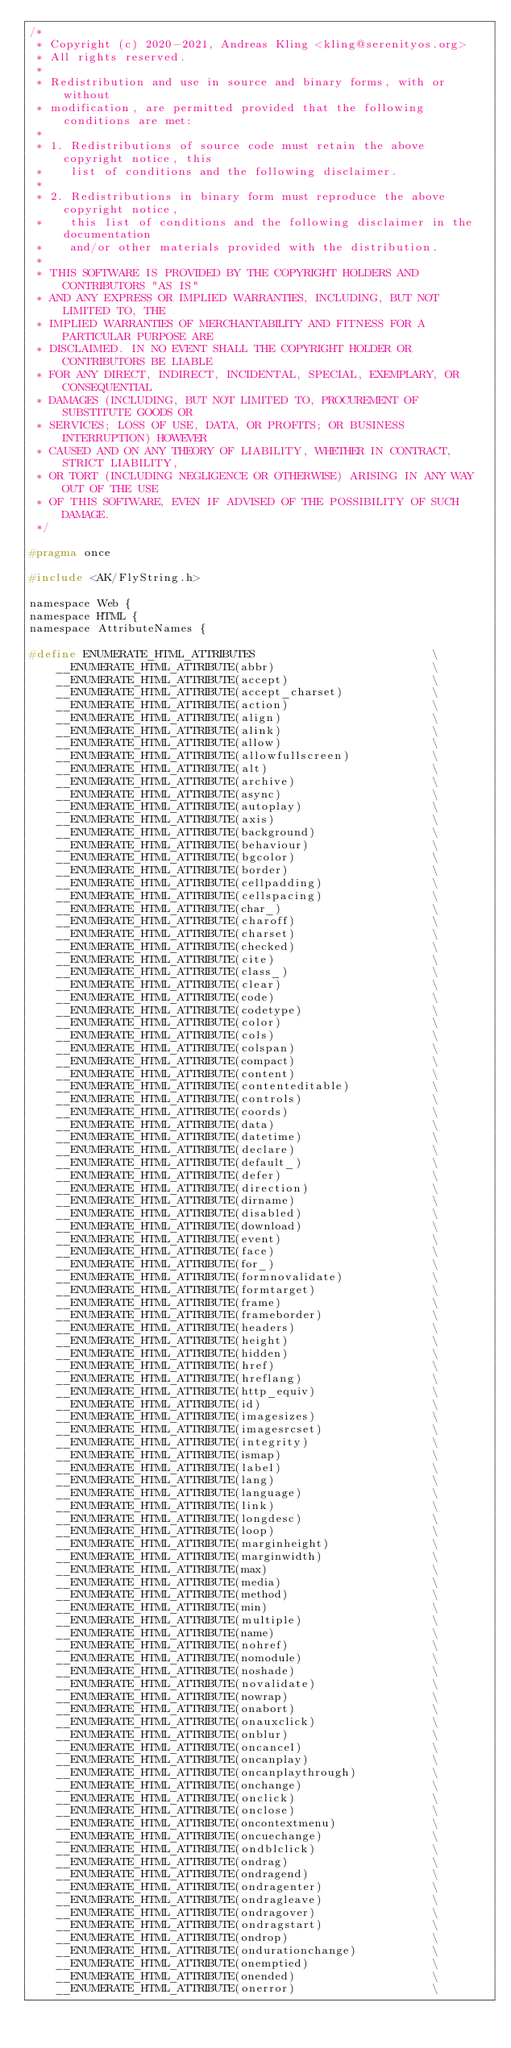Convert code to text. <code><loc_0><loc_0><loc_500><loc_500><_C_>/*
 * Copyright (c) 2020-2021, Andreas Kling <kling@serenityos.org>
 * All rights reserved.
 *
 * Redistribution and use in source and binary forms, with or without
 * modification, are permitted provided that the following conditions are met:
 *
 * 1. Redistributions of source code must retain the above copyright notice, this
 *    list of conditions and the following disclaimer.
 *
 * 2. Redistributions in binary form must reproduce the above copyright notice,
 *    this list of conditions and the following disclaimer in the documentation
 *    and/or other materials provided with the distribution.
 *
 * THIS SOFTWARE IS PROVIDED BY THE COPYRIGHT HOLDERS AND CONTRIBUTORS "AS IS"
 * AND ANY EXPRESS OR IMPLIED WARRANTIES, INCLUDING, BUT NOT LIMITED TO, THE
 * IMPLIED WARRANTIES OF MERCHANTABILITY AND FITNESS FOR A PARTICULAR PURPOSE ARE
 * DISCLAIMED. IN NO EVENT SHALL THE COPYRIGHT HOLDER OR CONTRIBUTORS BE LIABLE
 * FOR ANY DIRECT, INDIRECT, INCIDENTAL, SPECIAL, EXEMPLARY, OR CONSEQUENTIAL
 * DAMAGES (INCLUDING, BUT NOT LIMITED TO, PROCUREMENT OF SUBSTITUTE GOODS OR
 * SERVICES; LOSS OF USE, DATA, OR PROFITS; OR BUSINESS INTERRUPTION) HOWEVER
 * CAUSED AND ON ANY THEORY OF LIABILITY, WHETHER IN CONTRACT, STRICT LIABILITY,
 * OR TORT (INCLUDING NEGLIGENCE OR OTHERWISE) ARISING IN ANY WAY OUT OF THE USE
 * OF THIS SOFTWARE, EVEN IF ADVISED OF THE POSSIBILITY OF SUCH DAMAGE.
 */

#pragma once

#include <AK/FlyString.h>

namespace Web {
namespace HTML {
namespace AttributeNames {

#define ENUMERATE_HTML_ATTRIBUTES                          \
    __ENUMERATE_HTML_ATTRIBUTE(abbr)                       \
    __ENUMERATE_HTML_ATTRIBUTE(accept)                     \
    __ENUMERATE_HTML_ATTRIBUTE(accept_charset)             \
    __ENUMERATE_HTML_ATTRIBUTE(action)                     \
    __ENUMERATE_HTML_ATTRIBUTE(align)                      \
    __ENUMERATE_HTML_ATTRIBUTE(alink)                      \
    __ENUMERATE_HTML_ATTRIBUTE(allow)                      \
    __ENUMERATE_HTML_ATTRIBUTE(allowfullscreen)            \
    __ENUMERATE_HTML_ATTRIBUTE(alt)                        \
    __ENUMERATE_HTML_ATTRIBUTE(archive)                    \
    __ENUMERATE_HTML_ATTRIBUTE(async)                      \
    __ENUMERATE_HTML_ATTRIBUTE(autoplay)                   \
    __ENUMERATE_HTML_ATTRIBUTE(axis)                       \
    __ENUMERATE_HTML_ATTRIBUTE(background)                 \
    __ENUMERATE_HTML_ATTRIBUTE(behaviour)                  \
    __ENUMERATE_HTML_ATTRIBUTE(bgcolor)                    \
    __ENUMERATE_HTML_ATTRIBUTE(border)                     \
    __ENUMERATE_HTML_ATTRIBUTE(cellpadding)                \
    __ENUMERATE_HTML_ATTRIBUTE(cellspacing)                \
    __ENUMERATE_HTML_ATTRIBUTE(char_)                      \
    __ENUMERATE_HTML_ATTRIBUTE(charoff)                    \
    __ENUMERATE_HTML_ATTRIBUTE(charset)                    \
    __ENUMERATE_HTML_ATTRIBUTE(checked)                    \
    __ENUMERATE_HTML_ATTRIBUTE(cite)                       \
    __ENUMERATE_HTML_ATTRIBUTE(class_)                     \
    __ENUMERATE_HTML_ATTRIBUTE(clear)                      \
    __ENUMERATE_HTML_ATTRIBUTE(code)                       \
    __ENUMERATE_HTML_ATTRIBUTE(codetype)                   \
    __ENUMERATE_HTML_ATTRIBUTE(color)                      \
    __ENUMERATE_HTML_ATTRIBUTE(cols)                       \
    __ENUMERATE_HTML_ATTRIBUTE(colspan)                    \
    __ENUMERATE_HTML_ATTRIBUTE(compact)                    \
    __ENUMERATE_HTML_ATTRIBUTE(content)                    \
    __ENUMERATE_HTML_ATTRIBUTE(contenteditable)            \
    __ENUMERATE_HTML_ATTRIBUTE(controls)                   \
    __ENUMERATE_HTML_ATTRIBUTE(coords)                     \
    __ENUMERATE_HTML_ATTRIBUTE(data)                       \
    __ENUMERATE_HTML_ATTRIBUTE(datetime)                   \
    __ENUMERATE_HTML_ATTRIBUTE(declare)                    \
    __ENUMERATE_HTML_ATTRIBUTE(default_)                   \
    __ENUMERATE_HTML_ATTRIBUTE(defer)                      \
    __ENUMERATE_HTML_ATTRIBUTE(direction)                  \
    __ENUMERATE_HTML_ATTRIBUTE(dirname)                    \
    __ENUMERATE_HTML_ATTRIBUTE(disabled)                   \
    __ENUMERATE_HTML_ATTRIBUTE(download)                   \
    __ENUMERATE_HTML_ATTRIBUTE(event)                      \
    __ENUMERATE_HTML_ATTRIBUTE(face)                       \
    __ENUMERATE_HTML_ATTRIBUTE(for_)                       \
    __ENUMERATE_HTML_ATTRIBUTE(formnovalidate)             \
    __ENUMERATE_HTML_ATTRIBUTE(formtarget)                 \
    __ENUMERATE_HTML_ATTRIBUTE(frame)                      \
    __ENUMERATE_HTML_ATTRIBUTE(frameborder)                \
    __ENUMERATE_HTML_ATTRIBUTE(headers)                    \
    __ENUMERATE_HTML_ATTRIBUTE(height)                     \
    __ENUMERATE_HTML_ATTRIBUTE(hidden)                     \
    __ENUMERATE_HTML_ATTRIBUTE(href)                       \
    __ENUMERATE_HTML_ATTRIBUTE(hreflang)                   \
    __ENUMERATE_HTML_ATTRIBUTE(http_equiv)                 \
    __ENUMERATE_HTML_ATTRIBUTE(id)                         \
    __ENUMERATE_HTML_ATTRIBUTE(imagesizes)                 \
    __ENUMERATE_HTML_ATTRIBUTE(imagesrcset)                \
    __ENUMERATE_HTML_ATTRIBUTE(integrity)                  \
    __ENUMERATE_HTML_ATTRIBUTE(ismap)                      \
    __ENUMERATE_HTML_ATTRIBUTE(label)                      \
    __ENUMERATE_HTML_ATTRIBUTE(lang)                       \
    __ENUMERATE_HTML_ATTRIBUTE(language)                   \
    __ENUMERATE_HTML_ATTRIBUTE(link)                       \
    __ENUMERATE_HTML_ATTRIBUTE(longdesc)                   \
    __ENUMERATE_HTML_ATTRIBUTE(loop)                       \
    __ENUMERATE_HTML_ATTRIBUTE(marginheight)               \
    __ENUMERATE_HTML_ATTRIBUTE(marginwidth)                \
    __ENUMERATE_HTML_ATTRIBUTE(max)                        \
    __ENUMERATE_HTML_ATTRIBUTE(media)                      \
    __ENUMERATE_HTML_ATTRIBUTE(method)                     \
    __ENUMERATE_HTML_ATTRIBUTE(min)                        \
    __ENUMERATE_HTML_ATTRIBUTE(multiple)                   \
    __ENUMERATE_HTML_ATTRIBUTE(name)                       \
    __ENUMERATE_HTML_ATTRIBUTE(nohref)                     \
    __ENUMERATE_HTML_ATTRIBUTE(nomodule)                   \
    __ENUMERATE_HTML_ATTRIBUTE(noshade)                    \
    __ENUMERATE_HTML_ATTRIBUTE(novalidate)                 \
    __ENUMERATE_HTML_ATTRIBUTE(nowrap)                     \
    __ENUMERATE_HTML_ATTRIBUTE(onabort)                    \
    __ENUMERATE_HTML_ATTRIBUTE(onauxclick)                 \
    __ENUMERATE_HTML_ATTRIBUTE(onblur)                     \
    __ENUMERATE_HTML_ATTRIBUTE(oncancel)                   \
    __ENUMERATE_HTML_ATTRIBUTE(oncanplay)                  \
    __ENUMERATE_HTML_ATTRIBUTE(oncanplaythrough)           \
    __ENUMERATE_HTML_ATTRIBUTE(onchange)                   \
    __ENUMERATE_HTML_ATTRIBUTE(onclick)                    \
    __ENUMERATE_HTML_ATTRIBUTE(onclose)                    \
    __ENUMERATE_HTML_ATTRIBUTE(oncontextmenu)              \
    __ENUMERATE_HTML_ATTRIBUTE(oncuechange)                \
    __ENUMERATE_HTML_ATTRIBUTE(ondblclick)                 \
    __ENUMERATE_HTML_ATTRIBUTE(ondrag)                     \
    __ENUMERATE_HTML_ATTRIBUTE(ondragend)                  \
    __ENUMERATE_HTML_ATTRIBUTE(ondragenter)                \
    __ENUMERATE_HTML_ATTRIBUTE(ondragleave)                \
    __ENUMERATE_HTML_ATTRIBUTE(ondragover)                 \
    __ENUMERATE_HTML_ATTRIBUTE(ondragstart)                \
    __ENUMERATE_HTML_ATTRIBUTE(ondrop)                     \
    __ENUMERATE_HTML_ATTRIBUTE(ondurationchange)           \
    __ENUMERATE_HTML_ATTRIBUTE(onemptied)                  \
    __ENUMERATE_HTML_ATTRIBUTE(onended)                    \
    __ENUMERATE_HTML_ATTRIBUTE(onerror)                    \</code> 